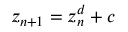<formula> <loc_0><loc_0><loc_500><loc_500>z _ { n + 1 } = z _ { n } ^ { d } + c</formula> 